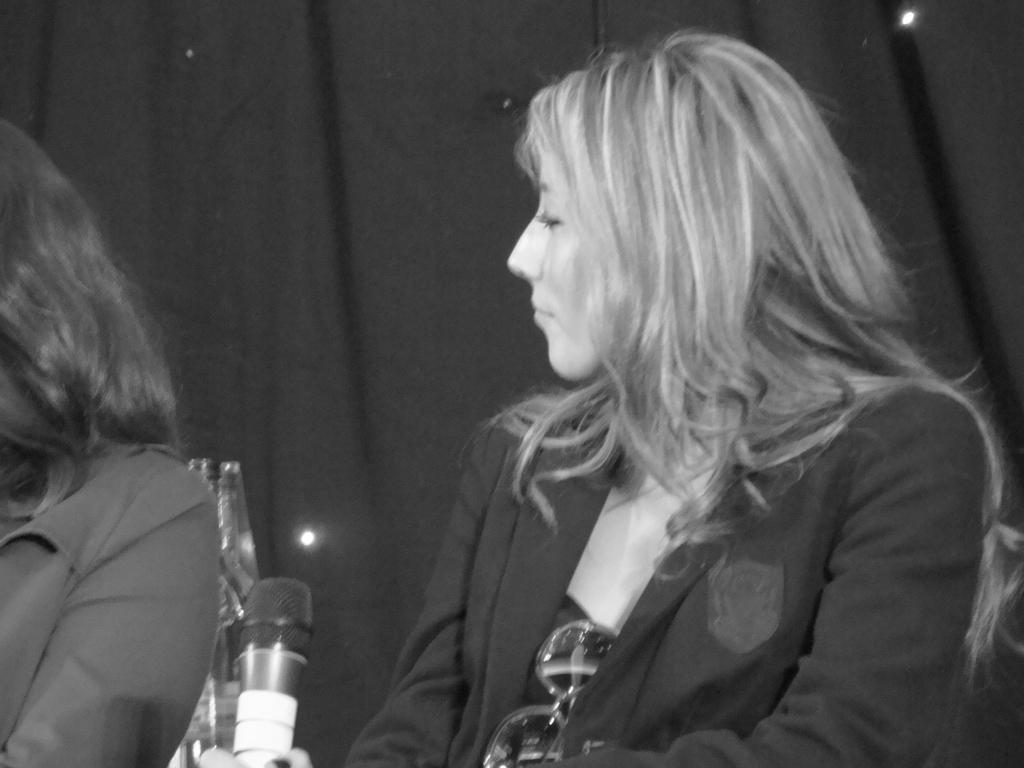How would you summarize this image in a sentence or two? This is a black and white image. In this image, in the middle, we can see a woman wearing a black color suit is sitting on the chair in front of a microphone. On the left side, we can also see hair and the hand of a person. In the background, we can see black color. 